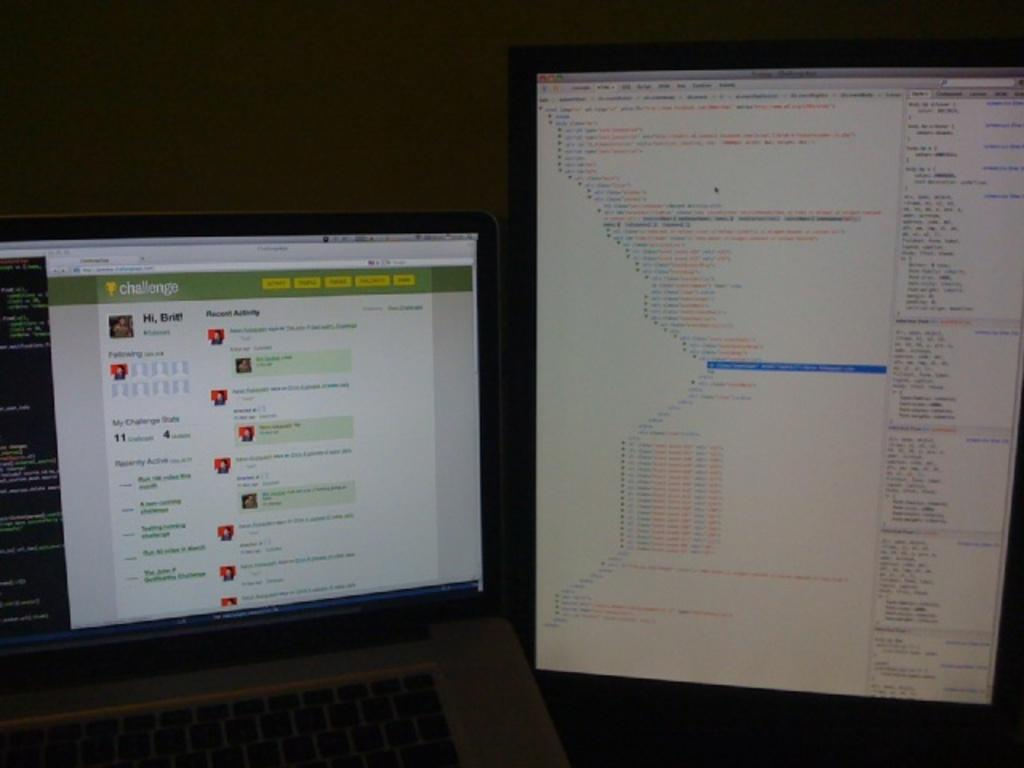What type of electronic device is located on the left side of the image? There is a laptop on the left side of the image. What type of electronic device is located on the right side of the image? There is a desktop computer on the right side of the image. Can you describe the arrangement of the electronic devices in the image? The laptop is on the left side, and the desktop computer is on the right side. How long does it take for the sisters to finish their work on the laptop in the image? There is no mention of sisters or work in the image, so we cannot determine how long it takes for them to finish their work. 